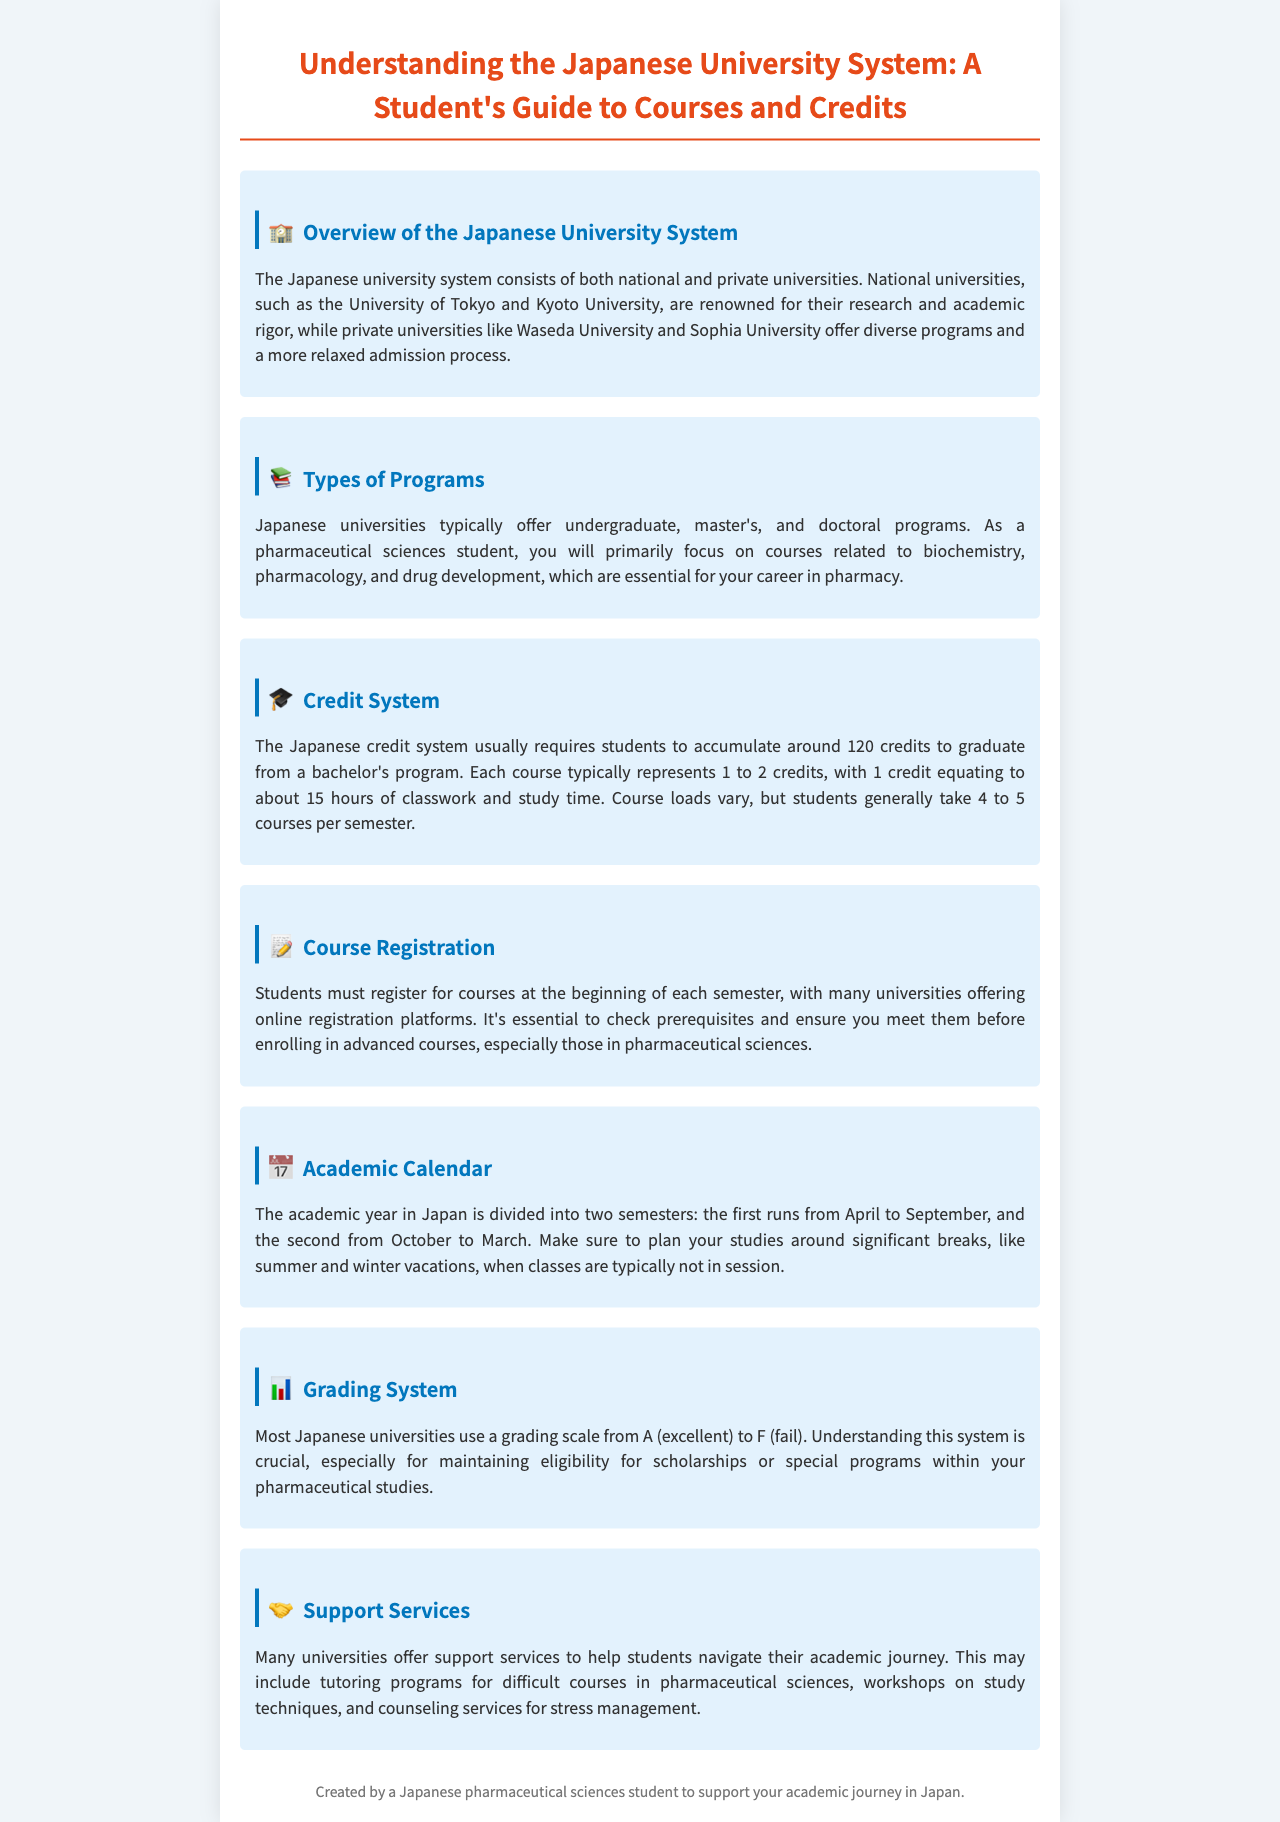What types of universities are mentioned? The document lists national and private universities as types mentioned in the Japanese university system.
Answer: national and private What is the focus of pharmaceutical sciences courses? The focus areas for pharmaceutical sciences students are specified in the document.
Answer: biochemistry, pharmacology, and drug development How many credits are generally required to graduate? The document specifies the number of credits required for graduation from a bachelor's program.
Answer: 120 credits What is the typical number of courses students take per semester? The document provides information on the usual course load per semester for students.
Answer: 4 to 5 courses What grading scale is used in most Japanese universities? The document outlines the grading scale commonly used in Japanese universities.
Answer: A to F How often must students register for courses? The document explains the course registration frequency for students.
Answer: each semester What services do many universities offer to support students? The types of support services mentioned in the document include various academic assistance resources.
Answer: tutoring programs When does the academic year start? The document states the start time of the academic year in Japan.
Answer: April 